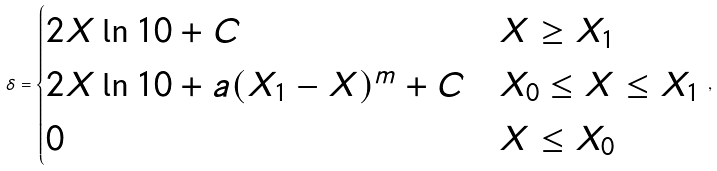Convert formula to latex. <formula><loc_0><loc_0><loc_500><loc_500>\delta = \begin{cases} 2 X \ln 1 0 + C & X \geq X _ { 1 } \\ 2 X \ln 1 0 + a ( X _ { 1 } - X ) ^ { m } + C & X _ { 0 } \leq X \leq X _ { 1 } \\ 0 & X \leq X _ { 0 } \end{cases} \, ,</formula> 